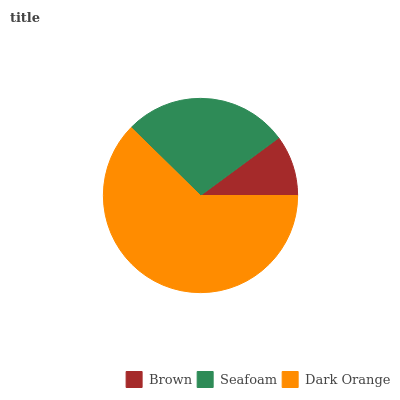Is Brown the minimum?
Answer yes or no. Yes. Is Dark Orange the maximum?
Answer yes or no. Yes. Is Seafoam the minimum?
Answer yes or no. No. Is Seafoam the maximum?
Answer yes or no. No. Is Seafoam greater than Brown?
Answer yes or no. Yes. Is Brown less than Seafoam?
Answer yes or no. Yes. Is Brown greater than Seafoam?
Answer yes or no. No. Is Seafoam less than Brown?
Answer yes or no. No. Is Seafoam the high median?
Answer yes or no. Yes. Is Seafoam the low median?
Answer yes or no. Yes. Is Brown the high median?
Answer yes or no. No. Is Dark Orange the low median?
Answer yes or no. No. 